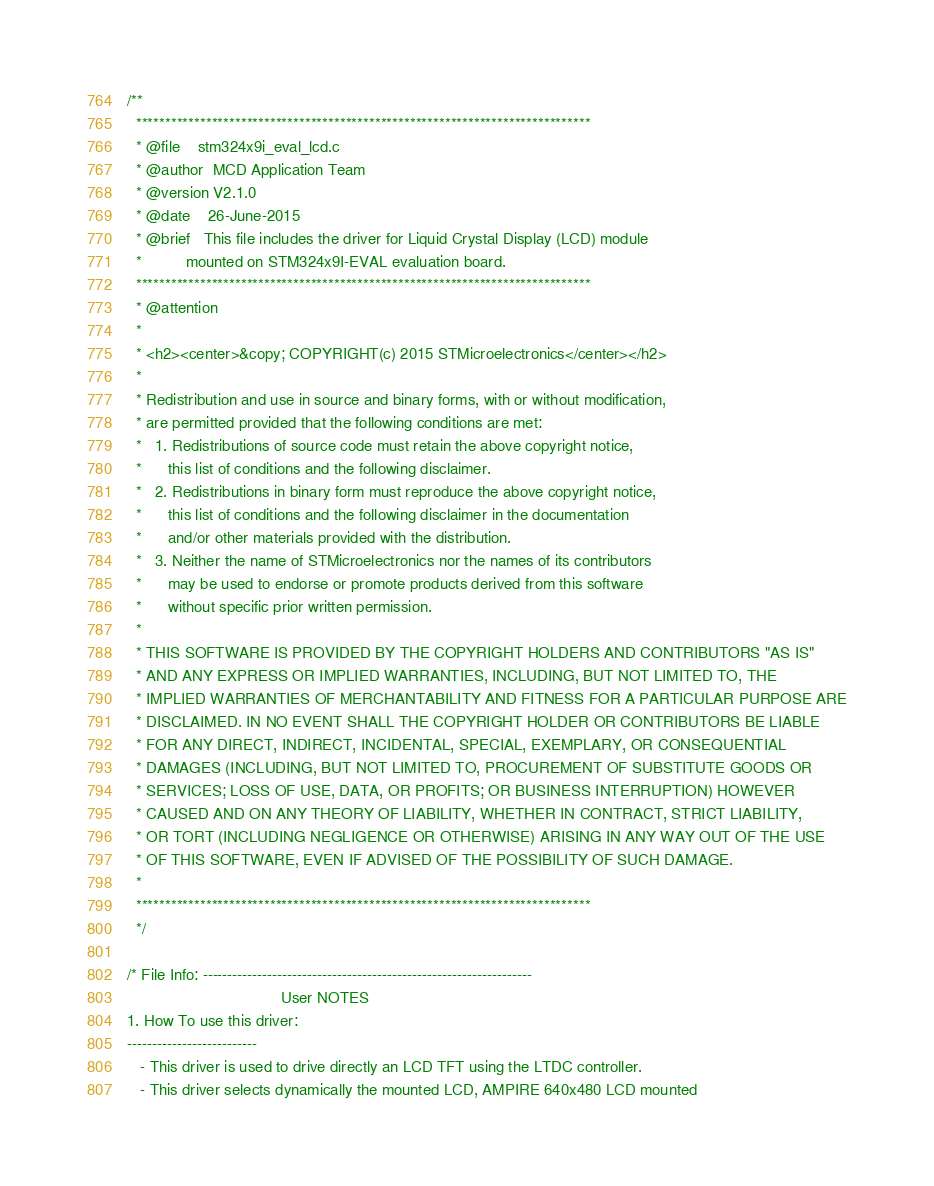<code> <loc_0><loc_0><loc_500><loc_500><_C_>/**
  ******************************************************************************
  * @file    stm324x9i_eval_lcd.c
  * @author  MCD Application Team
  * @version V2.1.0
  * @date    26-June-2015
  * @brief   This file includes the driver for Liquid Crystal Display (LCD) module
  *          mounted on STM324x9I-EVAL evaluation board.
  ******************************************************************************
  * @attention
  *
  * <h2><center>&copy; COPYRIGHT(c) 2015 STMicroelectronics</center></h2>
  *
  * Redistribution and use in source and binary forms, with or without modification,
  * are permitted provided that the following conditions are met:
  *   1. Redistributions of source code must retain the above copyright notice,
  *      this list of conditions and the following disclaimer.
  *   2. Redistributions in binary form must reproduce the above copyright notice,
  *      this list of conditions and the following disclaimer in the documentation
  *      and/or other materials provided with the distribution.
  *   3. Neither the name of STMicroelectronics nor the names of its contributors
  *      may be used to endorse or promote products derived from this software
  *      without specific prior written permission.
  *
  * THIS SOFTWARE IS PROVIDED BY THE COPYRIGHT HOLDERS AND CONTRIBUTORS "AS IS"
  * AND ANY EXPRESS OR IMPLIED WARRANTIES, INCLUDING, BUT NOT LIMITED TO, THE
  * IMPLIED WARRANTIES OF MERCHANTABILITY AND FITNESS FOR A PARTICULAR PURPOSE ARE
  * DISCLAIMED. IN NO EVENT SHALL THE COPYRIGHT HOLDER OR CONTRIBUTORS BE LIABLE
  * FOR ANY DIRECT, INDIRECT, INCIDENTAL, SPECIAL, EXEMPLARY, OR CONSEQUENTIAL
  * DAMAGES (INCLUDING, BUT NOT LIMITED TO, PROCUREMENT OF SUBSTITUTE GOODS OR
  * SERVICES; LOSS OF USE, DATA, OR PROFITS; OR BUSINESS INTERRUPTION) HOWEVER
  * CAUSED AND ON ANY THEORY OF LIABILITY, WHETHER IN CONTRACT, STRICT LIABILITY,
  * OR TORT (INCLUDING NEGLIGENCE OR OTHERWISE) ARISING IN ANY WAY OUT OF THE USE
  * OF THIS SOFTWARE, EVEN IF ADVISED OF THE POSSIBILITY OF SUCH DAMAGE.
  *
  ******************************************************************************
  */ 

/* File Info: ------------------------------------------------------------------
                                   User NOTES
1. How To use this driver:
--------------------------
   - This driver is used to drive directly an LCD TFT using the LTDC controller.
   - This driver selects dynamically the mounted LCD, AMPIRE 640x480 LCD mounted </code> 